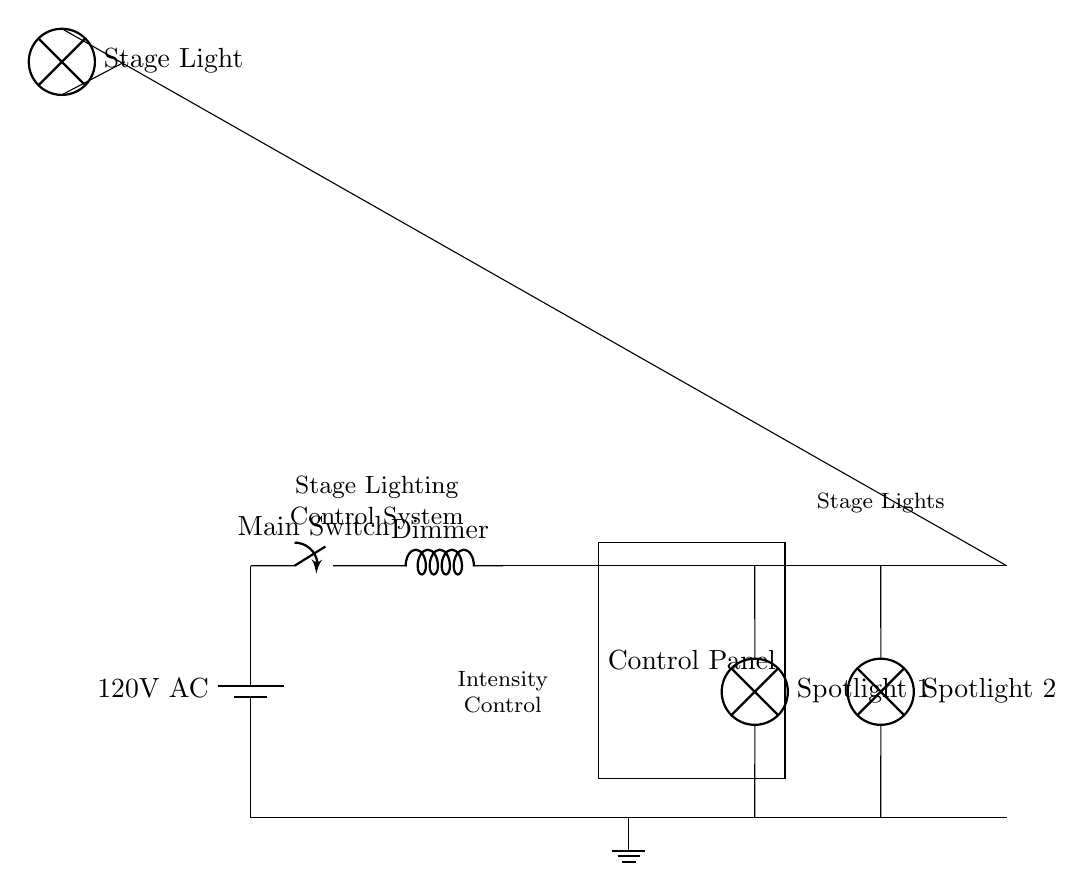What is the voltage supplied to the circuit? The voltage is labeled as 120 volts AC, which is indicated near the battery symbol representing the power supply.
Answer: 120 volts AC What component is used to adjust the light intensity? A dimmer is indicated in the circuit diagram, serving as the component responsible for adjusting the intensity of the lights.
Answer: Dimmer How many spotlight lamps are connected in the circuit? There are two spotlights shown in the circuit: Spotlight 1 and Spotlight 2, each represented as lamp symbols.
Answer: Two What is the purpose of the control panel in this circuit? The control panel is used to manipulate and adjust the settings for the stage lighting, although the specific functionalities are not delineated in this schematic.
Answer: Control settings Which component directly powers the stage lights? The main switch, which supplies power to the entire system, also provides power to the stage lights after the dimmer.
Answer: Main switch How are the ground connections represented in the circuit? The ground in the circuit is shown by a ground symbol connected to the bottom of the circuit, indicating the return path for electrical currents.
Answer: Ground symbol What is the arrangement of the stage lights in this circuit? The stage lights, namely Spotlight 1, Spotlight 2, and a Stage Light, are arranged in parallel configuration, as indicated by their separate paths from the dimmer to the ground.
Answer: Parallel arrangement 